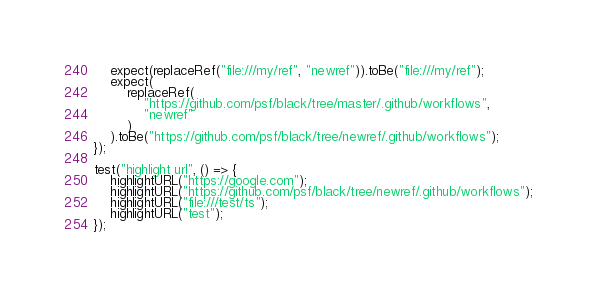Convert code to text. <code><loc_0><loc_0><loc_500><loc_500><_TypeScript_>    expect(replaceRef("file:///my/ref", "newref")).toBe("file:///my/ref");
    expect(
        replaceRef(
            "https://github.com/psf/black/tree/master/.github/workflows",
            "newref"
        )
    ).toBe("https://github.com/psf/black/tree/newref/.github/workflows");
});

test("highlight url", () => {
    highlightURL("https://google.com");
    highlightURL("https://github.com/psf/black/tree/newref/.github/workflows");
    highlightURL("file:///test/ts");
    highlightURL("test");
});
</code> 